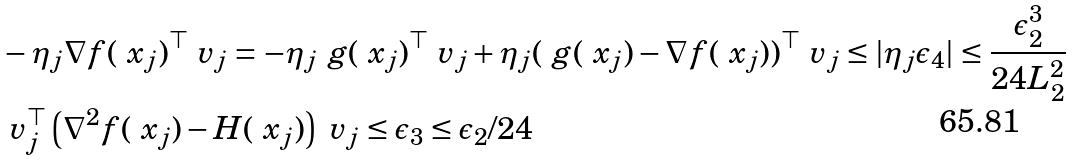<formula> <loc_0><loc_0><loc_500><loc_500>& - \eta _ { j } \nabla f ( \ x _ { j } ) ^ { \top } \ v _ { j } = - \eta _ { j } \ g ( \ x _ { j } ) ^ { \top } \ v _ { j } + \eta _ { j } ( \ g ( \ x _ { j } ) - \nabla f ( \ x _ { j } ) ) ^ { \top } \ v _ { j } \leq | \eta _ { j } \epsilon _ { 4 } | \leq \frac { \epsilon _ { 2 } ^ { 3 } } { 2 4 L _ { 2 } ^ { 2 } } \\ & \ v _ { j } ^ { \top } \left ( \nabla ^ { 2 } f ( \ x _ { j } ) - H ( \ x _ { j } ) \right ) \ v _ { j } \leq \epsilon _ { 3 } \leq \epsilon _ { 2 } / 2 4</formula> 